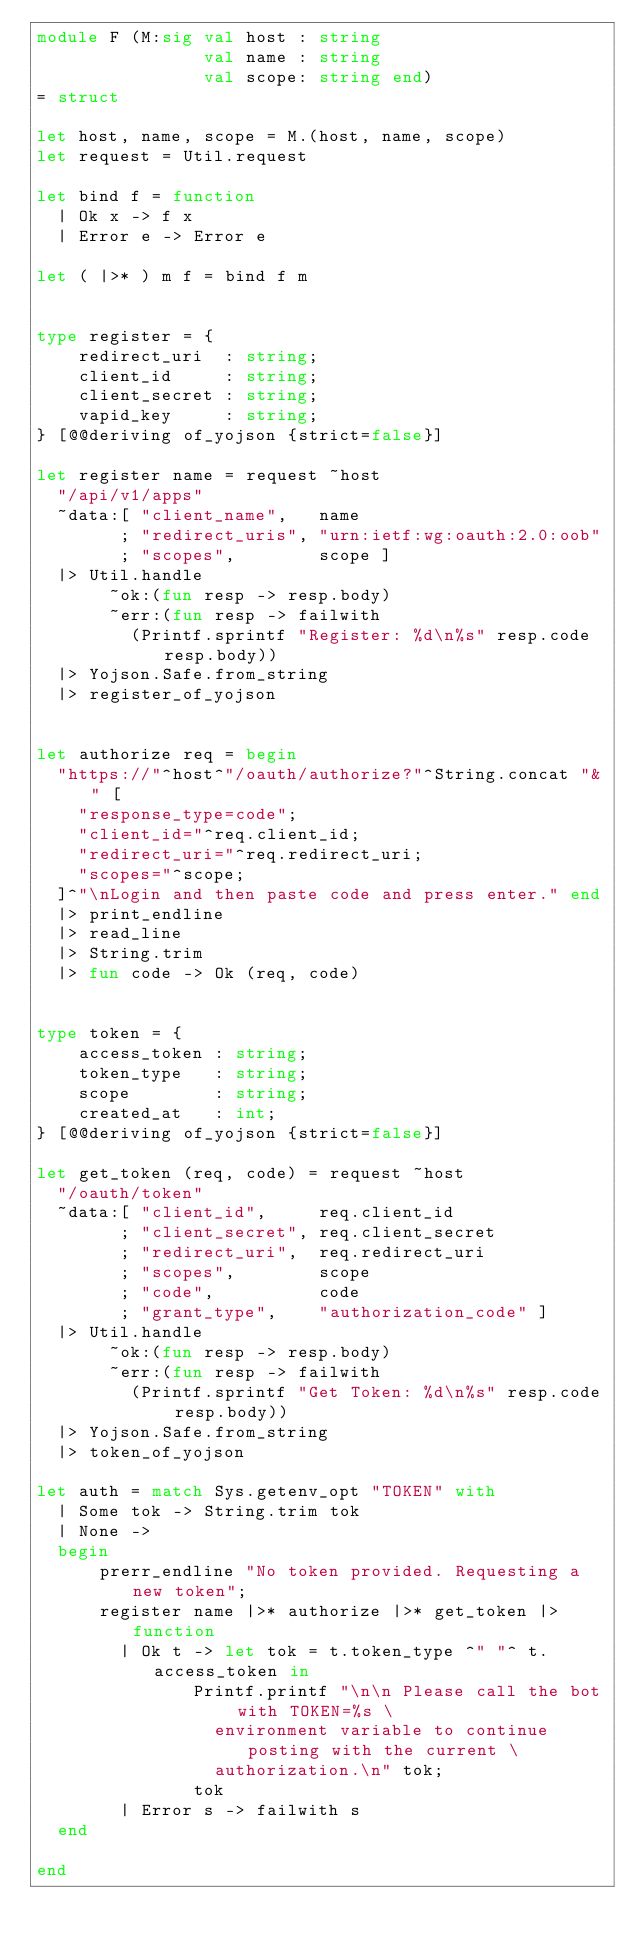Convert code to text. <code><loc_0><loc_0><loc_500><loc_500><_OCaml_>module F (M:sig val host : string
                val name : string
                val scope: string end)
= struct

let host, name, scope = M.(host, name, scope)
let request = Util.request

let bind f = function
  | Ok x -> f x
  | Error e -> Error e

let ( |>* ) m f = bind f m


type register = {
	redirect_uri  : string;
	client_id     : string;
	client_secret : string;
	vapid_key     : string;
} [@@deriving of_yojson {strict=false}]

let register name = request ~host
  "/api/v1/apps"
  ~data:[ "client_name",   name
        ; "redirect_uris", "urn:ietf:wg:oauth:2.0:oob"
        ; "scopes",        scope ]
  |> Util.handle
       ~ok:(fun resp -> resp.body) 
       ~err:(fun resp -> failwith
         (Printf.sprintf "Register: %d\n%s" resp.code resp.body))
  |> Yojson.Safe.from_string
  |> register_of_yojson


let authorize req = begin
  "https://"^host^"/oauth/authorize?"^String.concat "&" [
    "response_type=code";
    "client_id="^req.client_id;
    "redirect_uri="^req.redirect_uri;
    "scopes="^scope;
  ]^"\nLogin and then paste code and press enter." end
  |> print_endline
  |> read_line
  |> String.trim
  |> fun code -> Ok (req, code)


type token = {
	access_token : string;
	token_type   : string;
	scope        : string;
	created_at   : int;
} [@@deriving of_yojson {strict=false}]

let get_token (req, code) = request ~host
  "/oauth/token"
  ~data:[ "client_id",     req.client_id
        ; "client_secret", req.client_secret
        ; "redirect_uri",  req.redirect_uri
        ; "scopes",        scope
        ; "code",          code
        ; "grant_type",    "authorization_code" ]
  |> Util.handle
       ~ok:(fun resp -> resp.body) 
       ~err:(fun resp -> failwith
         (Printf.sprintf "Get Token: %d\n%s" resp.code resp.body))
  |> Yojson.Safe.from_string
  |> token_of_yojson

let auth = match Sys.getenv_opt "TOKEN" with
  | Some tok -> String.trim tok
  | None ->
  begin
      prerr_endline "No token provided. Requesting a new token";
      register name |>* authorize |>* get_token |> function
        | Ok t -> let tok = t.token_type ^" "^ t.access_token in
               Printf.printf "\n\n Please call the bot with TOKEN=%s \
                 environment variable to continue posting with the current \
                 authorization.\n" tok;
               tok
        | Error s -> failwith s
  end

end
</code> 